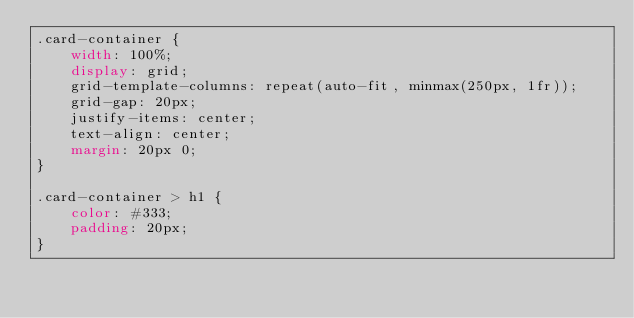<code> <loc_0><loc_0><loc_500><loc_500><_CSS_>.card-container {
    width: 100%;
    display: grid;
    grid-template-columns: repeat(auto-fit, minmax(250px, 1fr));
    grid-gap: 20px;
    justify-items: center;
    text-align: center;
    margin: 20px 0;
}

.card-container > h1 {
    color: #333;
    padding: 20px;
}</code> 